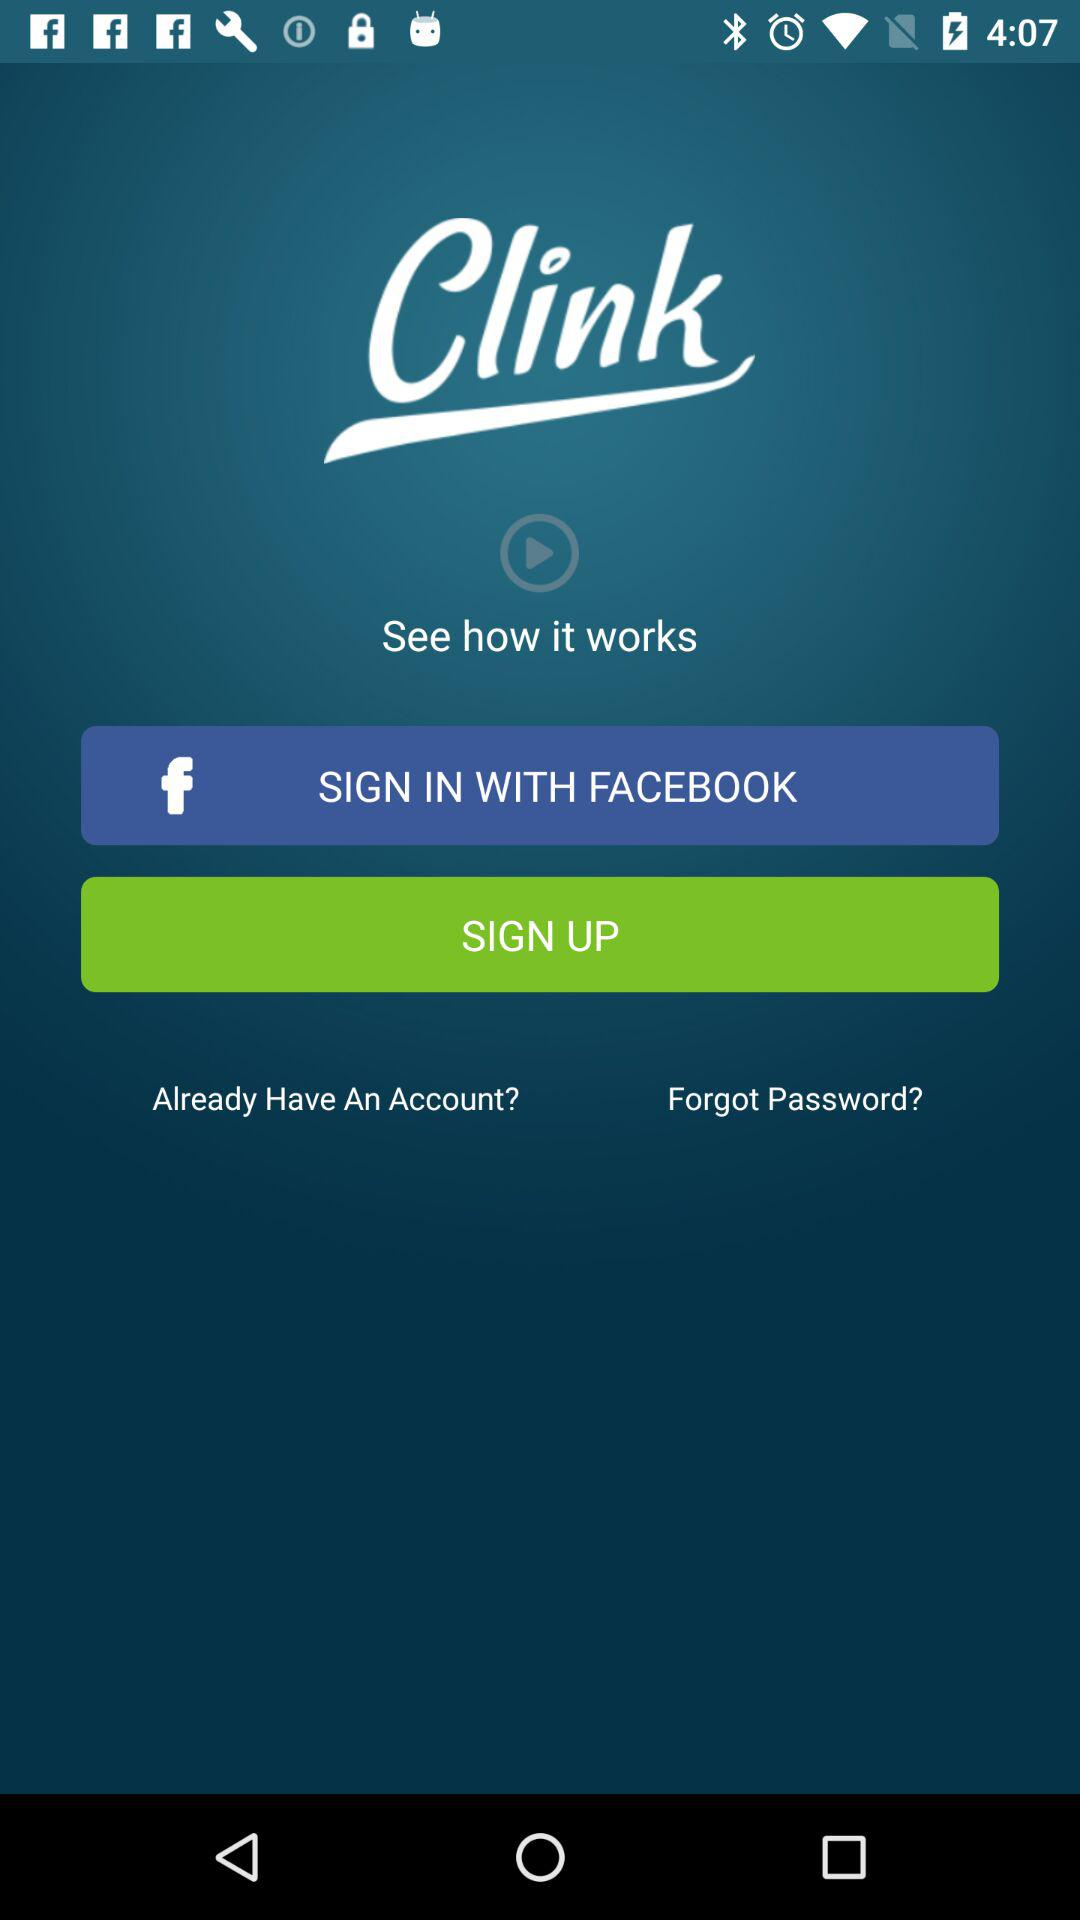What is the application name? The application name is "Clink". 